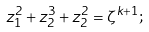Convert formula to latex. <formula><loc_0><loc_0><loc_500><loc_500>z _ { 1 } ^ { 2 } + z _ { 2 } ^ { 3 } + z _ { 2 } ^ { 2 } = \zeta ^ { k + 1 } ;</formula> 